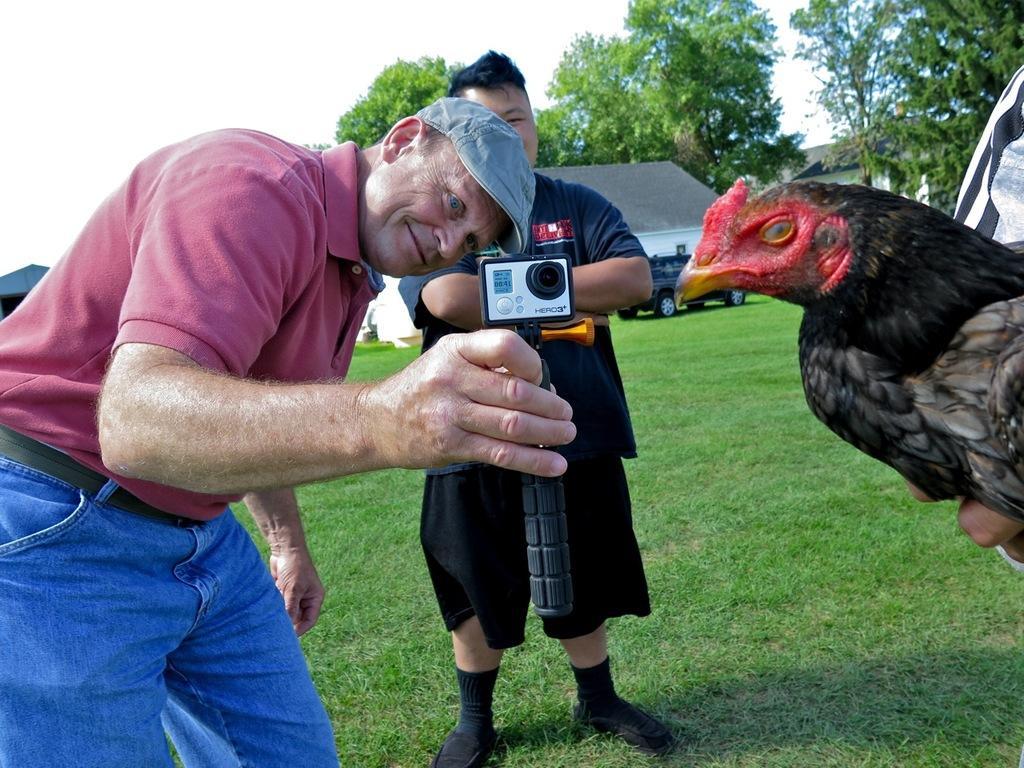In one or two sentences, can you explain what this image depicts? In this image I can see a man wearing pink t shirt, blue jeans and hat is standing and holding a black colored object in his hand. To the right side of the image I can see a hen which is black, red and brown in color and I can see another person wearing black dress is standing on the ground. In the background I can see few buildings, a car, few trees and the sky. 